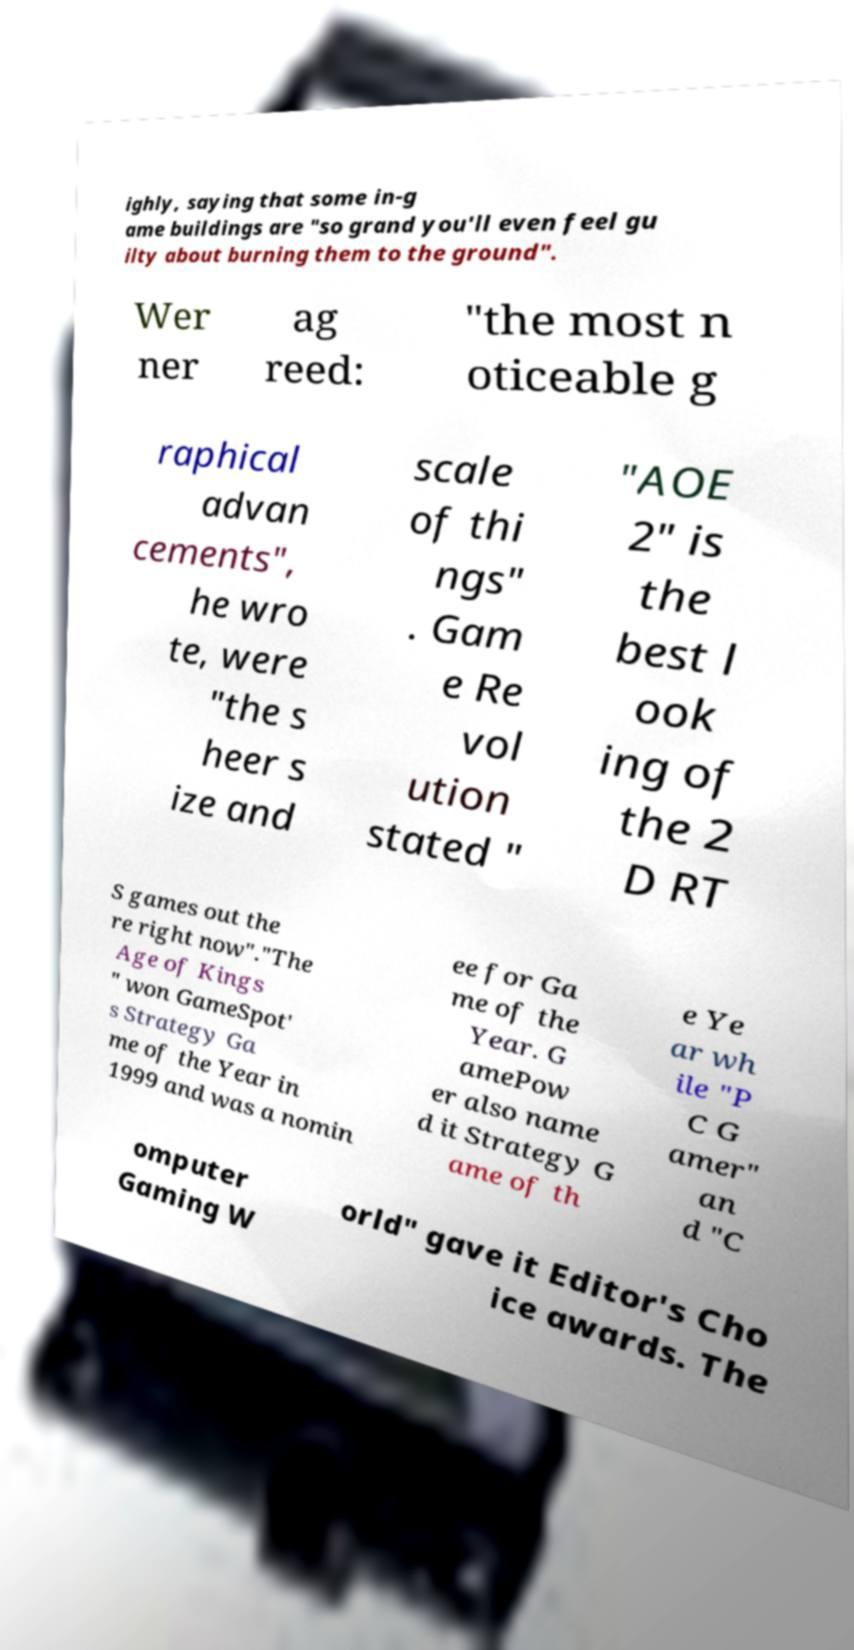There's text embedded in this image that I need extracted. Can you transcribe it verbatim? ighly, saying that some in-g ame buildings are "so grand you'll even feel gu ilty about burning them to the ground". Wer ner ag reed: "the most n oticeable g raphical advan cements", he wro te, were "the s heer s ize and scale of thi ngs" . Gam e Re vol ution stated " "AOE 2" is the best l ook ing of the 2 D RT S games out the re right now"."The Age of Kings " won GameSpot' s Strategy Ga me of the Year in 1999 and was a nomin ee for Ga me of the Year. G amePow er also name d it Strategy G ame of th e Ye ar wh ile "P C G amer" an d "C omputer Gaming W orld" gave it Editor's Cho ice awards. The 